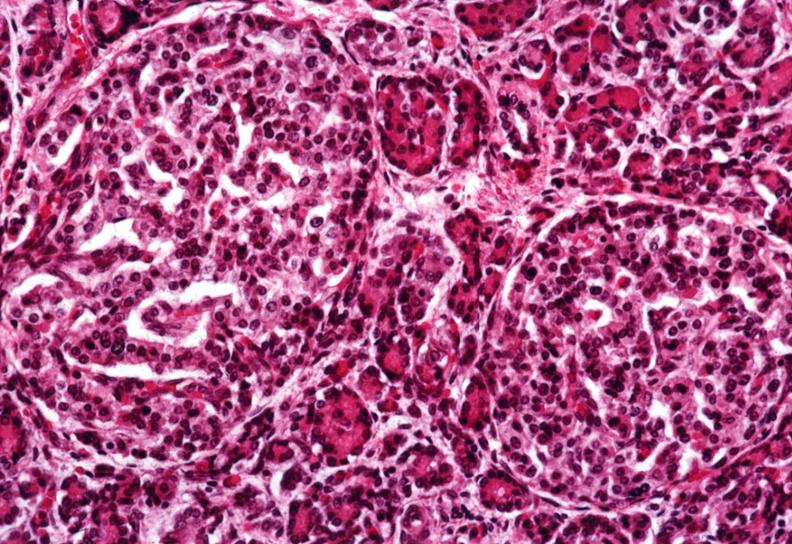s pancreas present?
Answer the question using a single word or phrase. Yes 